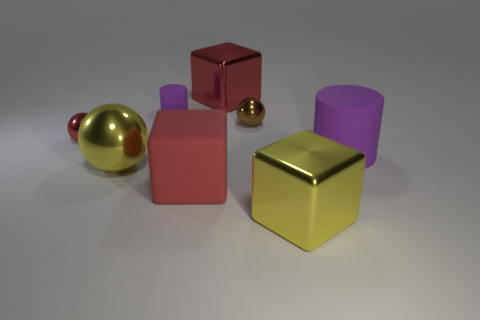What is the size of the sphere in front of the big purple matte thing?
Offer a very short reply. Large. There is a purple object that is the same material as the large cylinder; what is its shape?
Ensure brevity in your answer.  Cylinder. Is the tiny brown thing made of the same material as the red object that is left of the tiny cylinder?
Offer a terse response. Yes. There is a purple object on the left side of the large rubber block; does it have the same shape as the big purple object?
Ensure brevity in your answer.  Yes. There is a large purple object that is the same shape as the tiny purple thing; what material is it?
Provide a succinct answer. Rubber. Does the small red shiny object have the same shape as the small metallic object on the right side of the tiny red metallic object?
Your answer should be very brief. Yes. The object that is on the left side of the matte block and behind the brown metal ball is what color?
Give a very brief answer. Purple. Are any red matte cubes visible?
Provide a succinct answer. Yes. Are there the same number of brown metal things that are on the left side of the yellow ball and purple objects?
Provide a short and direct response. No. How many other objects are the same shape as the big red metal object?
Offer a very short reply. 2. 